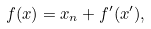<formula> <loc_0><loc_0><loc_500><loc_500>f ( x ) = x _ { n } + f ^ { \prime } ( x ^ { \prime } ) ,</formula> 